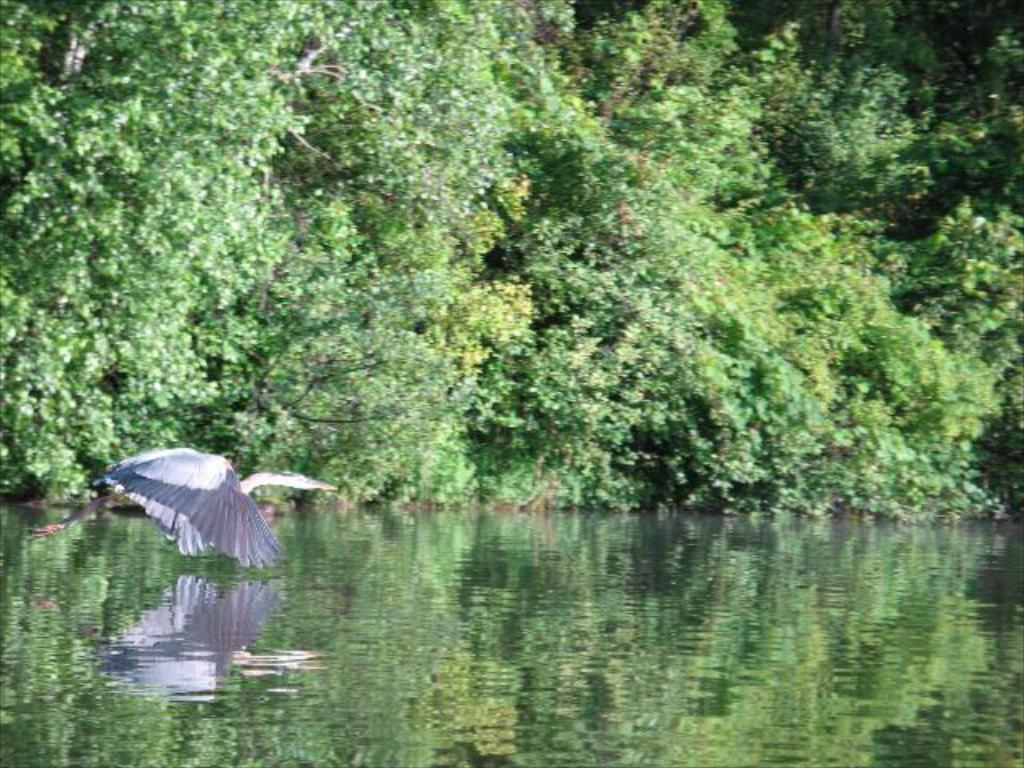What is located at the bottom of the image? There is a river at the bottom of the image. What can be seen on the left side of the image? There is a bird on the left side of the image. What type of vegetation is visible in the background of the image? There are trees in the background of the image. What type of hen is depicted in the prose of the image? There is no hen or prose present in the image; it features a river, a bird, and trees. 